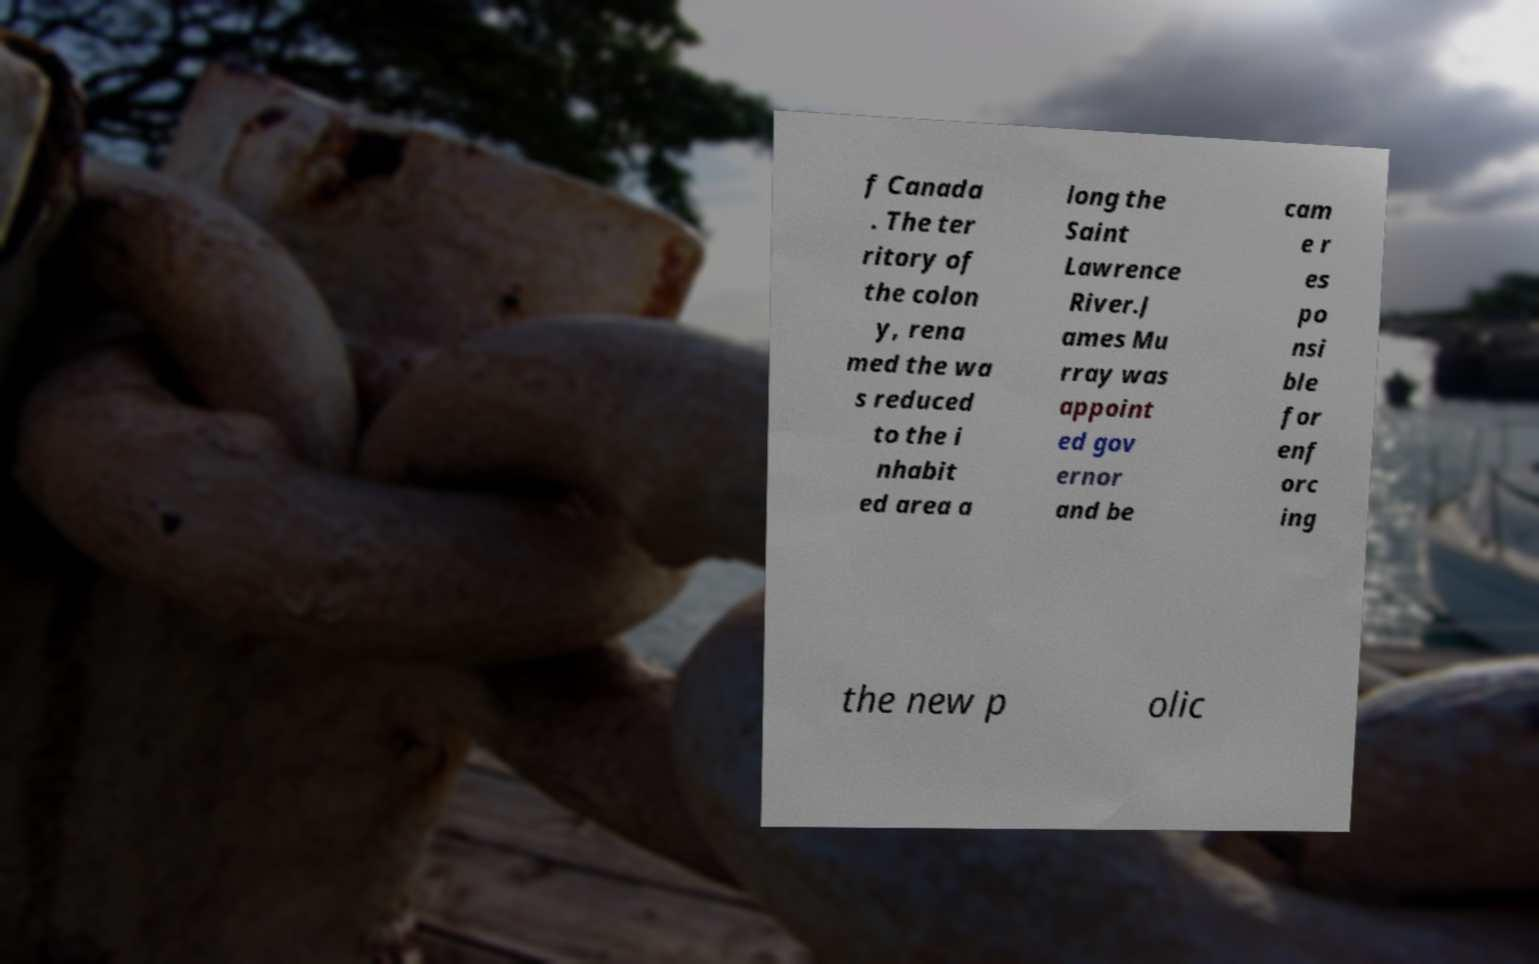Please identify and transcribe the text found in this image. f Canada . The ter ritory of the colon y, rena med the wa s reduced to the i nhabit ed area a long the Saint Lawrence River.J ames Mu rray was appoint ed gov ernor and be cam e r es po nsi ble for enf orc ing the new p olic 